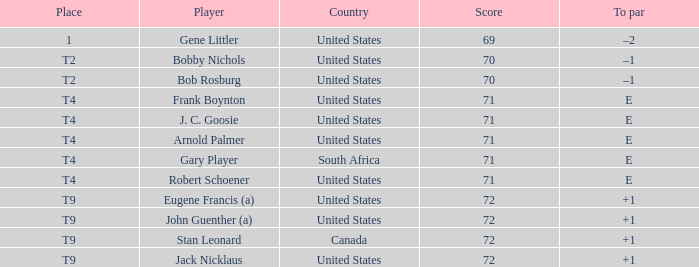Parse the table in full. {'header': ['Place', 'Player', 'Country', 'Score', 'To par'], 'rows': [['1', 'Gene Littler', 'United States', '69', '–2'], ['T2', 'Bobby Nichols', 'United States', '70', '–1'], ['T2', 'Bob Rosburg', 'United States', '70', '–1'], ['T4', 'Frank Boynton', 'United States', '71', 'E'], ['T4', 'J. C. Goosie', 'United States', '71', 'E'], ['T4', 'Arnold Palmer', 'United States', '71', 'E'], ['T4', 'Gary Player', 'South Africa', '71', 'E'], ['T4', 'Robert Schoener', 'United States', '71', 'E'], ['T9', 'Eugene Francis (a)', 'United States', '72', '+1'], ['T9', 'John Guenther (a)', 'United States', '72', '+1'], ['T9', 'Stan Leonard', 'Canada', '72', '+1'], ['T9', 'Jack Nicklaus', 'United States', '72', '+1']]} What is To Par, when Country is "United States", when Place is "T4", and when Player is "Arnold Palmer"? E. 